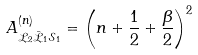<formula> <loc_0><loc_0><loc_500><loc_500>A ^ { ( n ) } _ { \mathcal { L } _ { 2 } \bar { \mathcal { L } } _ { 1 } \mathcal { S } _ { 1 } } & = \left ( n + \frac { 1 } { 2 } + \frac { \beta } { 2 } \right ) ^ { 2 }</formula> 